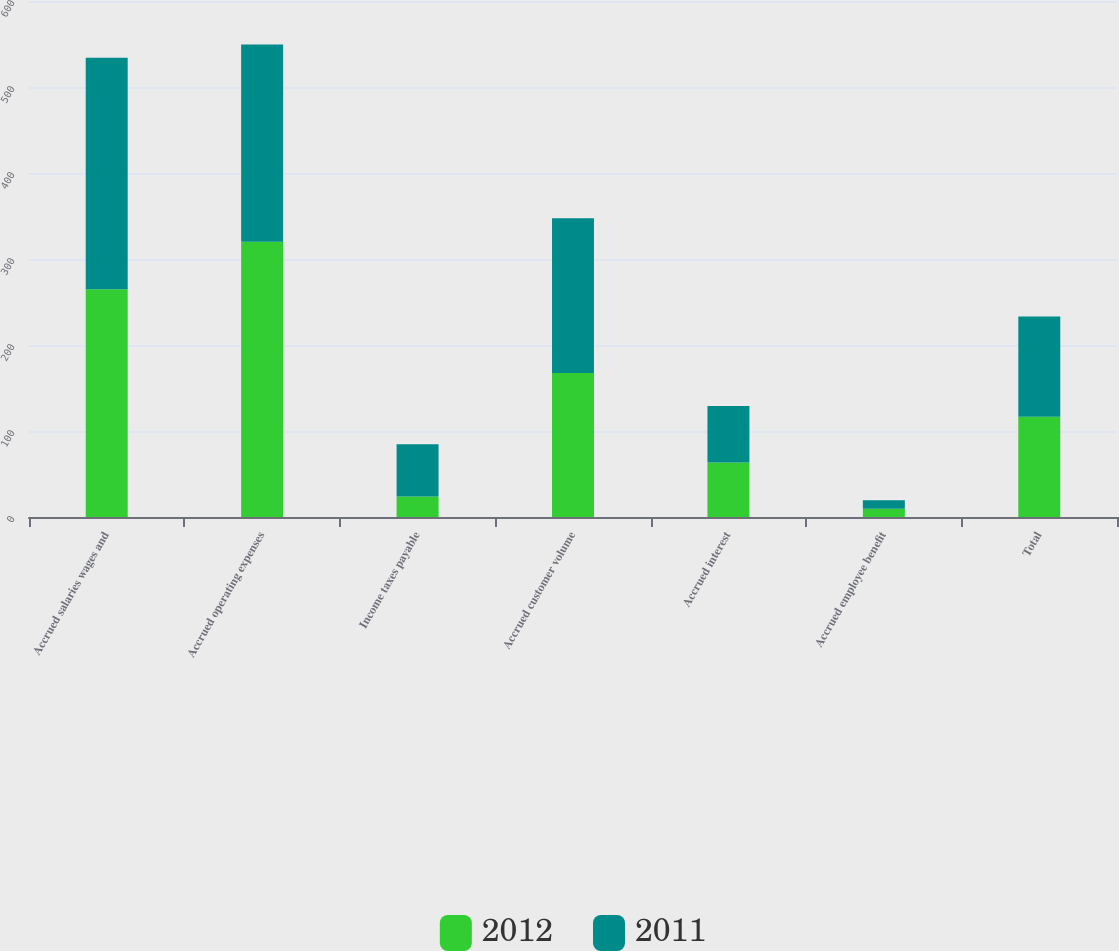<chart> <loc_0><loc_0><loc_500><loc_500><stacked_bar_chart><ecel><fcel>Accrued salaries wages and<fcel>Accrued operating expenses<fcel>Income taxes payable<fcel>Accrued customer volume<fcel>Accrued interest<fcel>Accrued employee benefit<fcel>Total<nl><fcel>2012<fcel>264.8<fcel>320.1<fcel>23.8<fcel>167.4<fcel>63.4<fcel>9.7<fcel>116.5<nl><fcel>2011<fcel>269.2<fcel>229.2<fcel>60.8<fcel>180.1<fcel>65.6<fcel>9.8<fcel>116.5<nl></chart> 